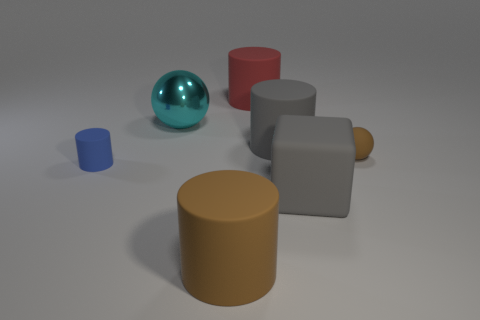There is a ball that is right of the big red rubber cylinder that is behind the big cube; what size is it?
Offer a very short reply. Small. How many small brown rubber things have the same shape as the big brown object?
Offer a terse response. 0. Are there any other things that are the same shape as the tiny brown matte object?
Ensure brevity in your answer.  Yes. Are there any small metallic cylinders that have the same color as the big matte block?
Offer a terse response. No. Are the large gray thing that is left of the gray rubber cube and the brown object right of the gray matte block made of the same material?
Offer a very short reply. Yes. What is the color of the large rubber cube?
Your answer should be very brief. Gray. There is a gray rubber thing behind the rubber ball that is in front of the matte thing behind the metal sphere; what is its size?
Make the answer very short. Large. How many other things are there of the same size as the blue cylinder?
Offer a terse response. 1. What number of blue things are the same material as the tiny cylinder?
Provide a short and direct response. 0. There is a big object behind the cyan object; what shape is it?
Ensure brevity in your answer.  Cylinder. 